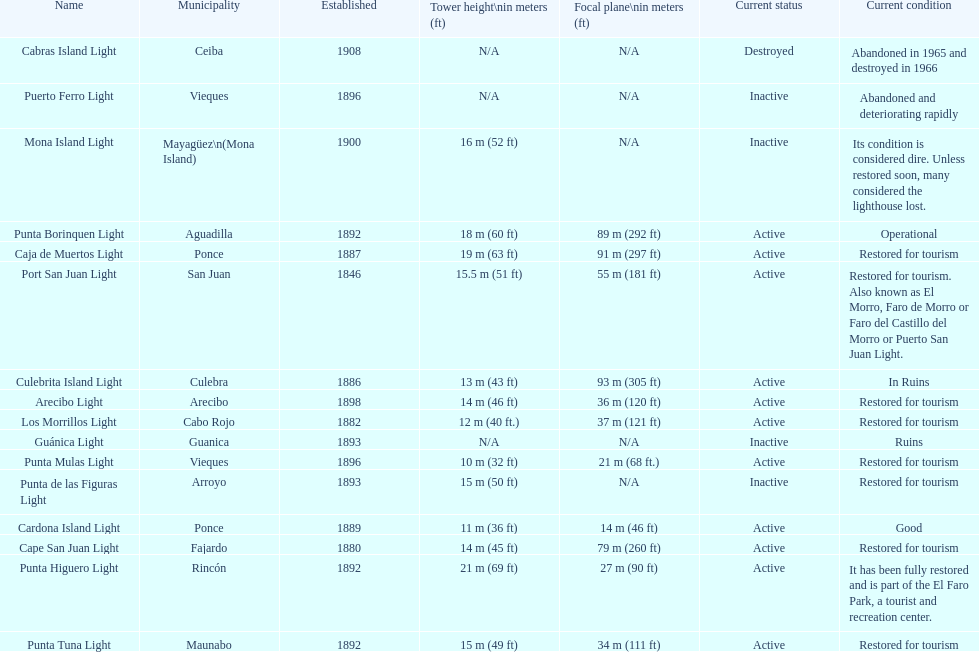Number of lighthouses that begin with the letter p 7. 